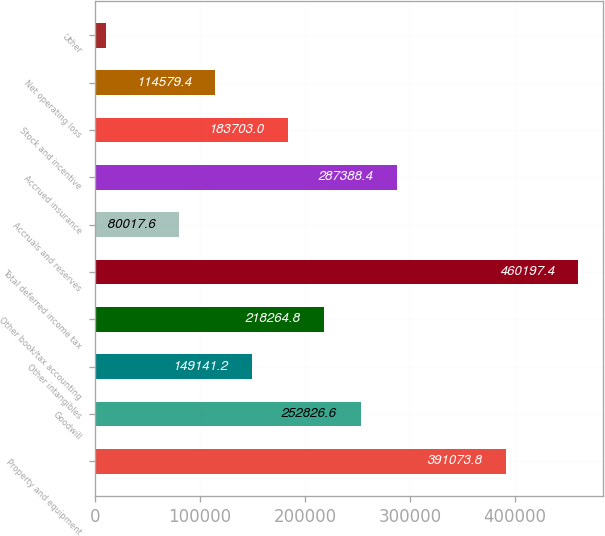Convert chart to OTSL. <chart><loc_0><loc_0><loc_500><loc_500><bar_chart><fcel>Property and equipment<fcel>Goodwill<fcel>Other intangibles<fcel>Other book/tax accounting<fcel>Total deferred income tax<fcel>Accruals and reserves<fcel>Accrued insurance<fcel>Stock and incentive<fcel>Net operating loss<fcel>Other<nl><fcel>391074<fcel>252827<fcel>149141<fcel>218265<fcel>460197<fcel>80017.6<fcel>287388<fcel>183703<fcel>114579<fcel>10894<nl></chart> 